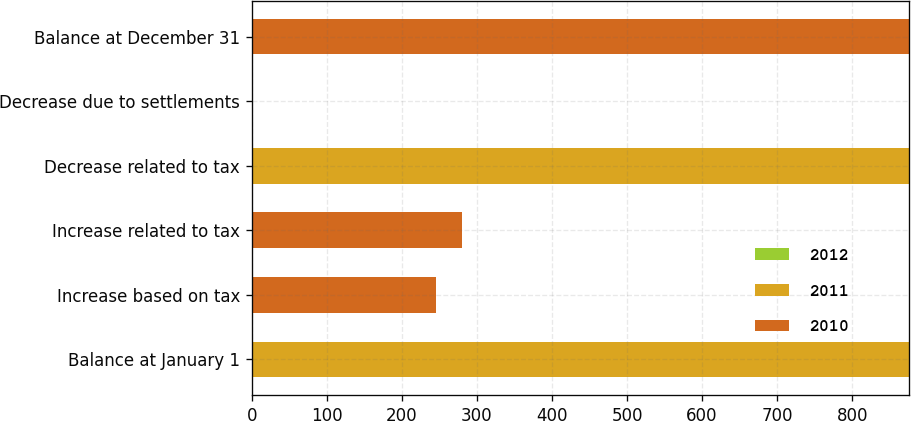<chart> <loc_0><loc_0><loc_500><loc_500><stacked_bar_chart><ecel><fcel>Balance at January 1<fcel>Increase based on tax<fcel>Increase related to tax<fcel>Decrease related to tax<fcel>Decrease due to settlements<fcel>Balance at December 31<nl><fcel>2012<fcel>0<fcel>0<fcel>0<fcel>0<fcel>0<fcel>0<nl><fcel>2011<fcel>875<fcel>0<fcel>0<fcel>875<fcel>0<fcel>0<nl><fcel>2010<fcel>0<fcel>245<fcel>280<fcel>0<fcel>0<fcel>875<nl></chart> 